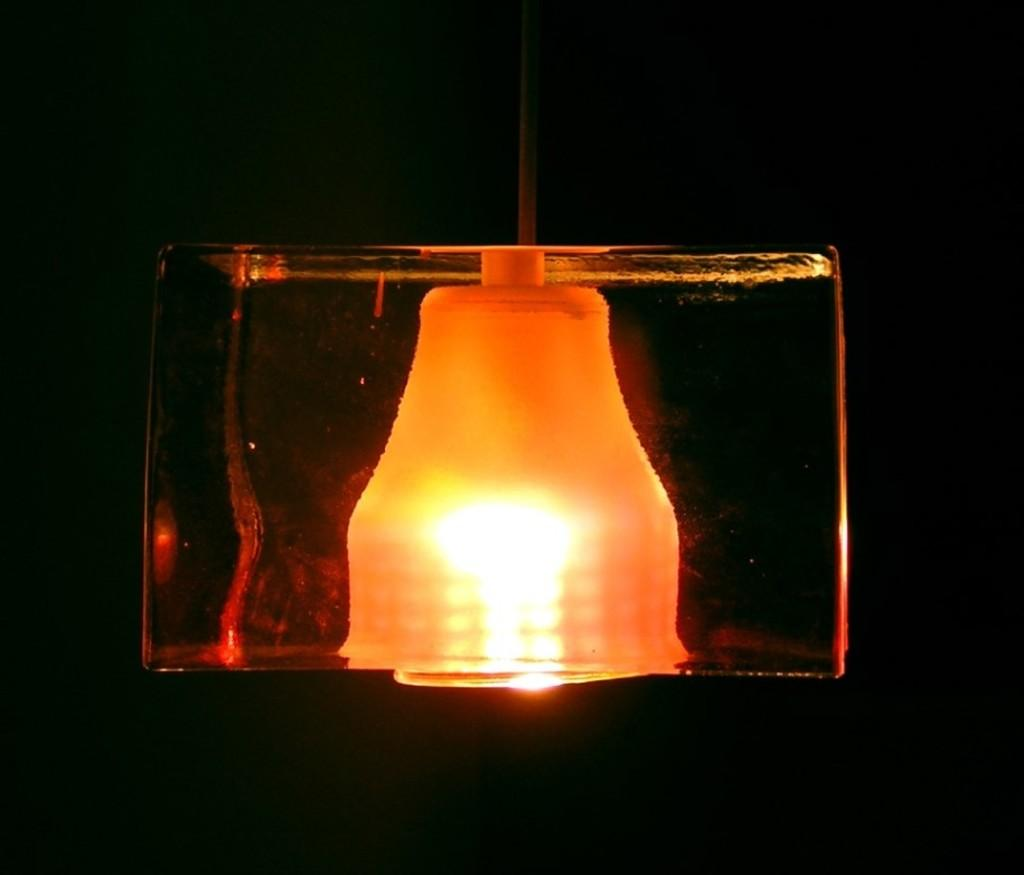What object can be seen in the image? There is a lamp in the image. How many jellyfish are swimming around the lamp in the image? There are no jellyfish present in the image; it only features a lamp. What type of news is being reported by the lamp in the image? The lamp is not reporting any news; it is an inanimate object. 